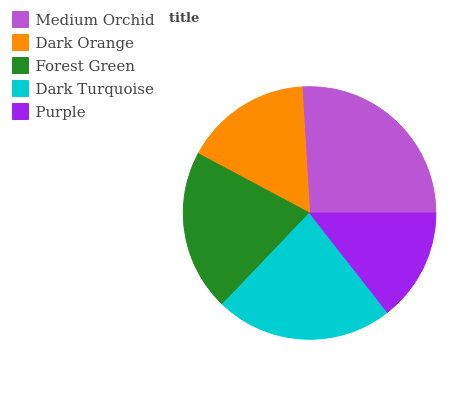Is Purple the minimum?
Answer yes or no. Yes. Is Medium Orchid the maximum?
Answer yes or no. Yes. Is Dark Orange the minimum?
Answer yes or no. No. Is Dark Orange the maximum?
Answer yes or no. No. Is Medium Orchid greater than Dark Orange?
Answer yes or no. Yes. Is Dark Orange less than Medium Orchid?
Answer yes or no. Yes. Is Dark Orange greater than Medium Orchid?
Answer yes or no. No. Is Medium Orchid less than Dark Orange?
Answer yes or no. No. Is Forest Green the high median?
Answer yes or no. Yes. Is Forest Green the low median?
Answer yes or no. Yes. Is Dark Turquoise the high median?
Answer yes or no. No. Is Dark Orange the low median?
Answer yes or no. No. 